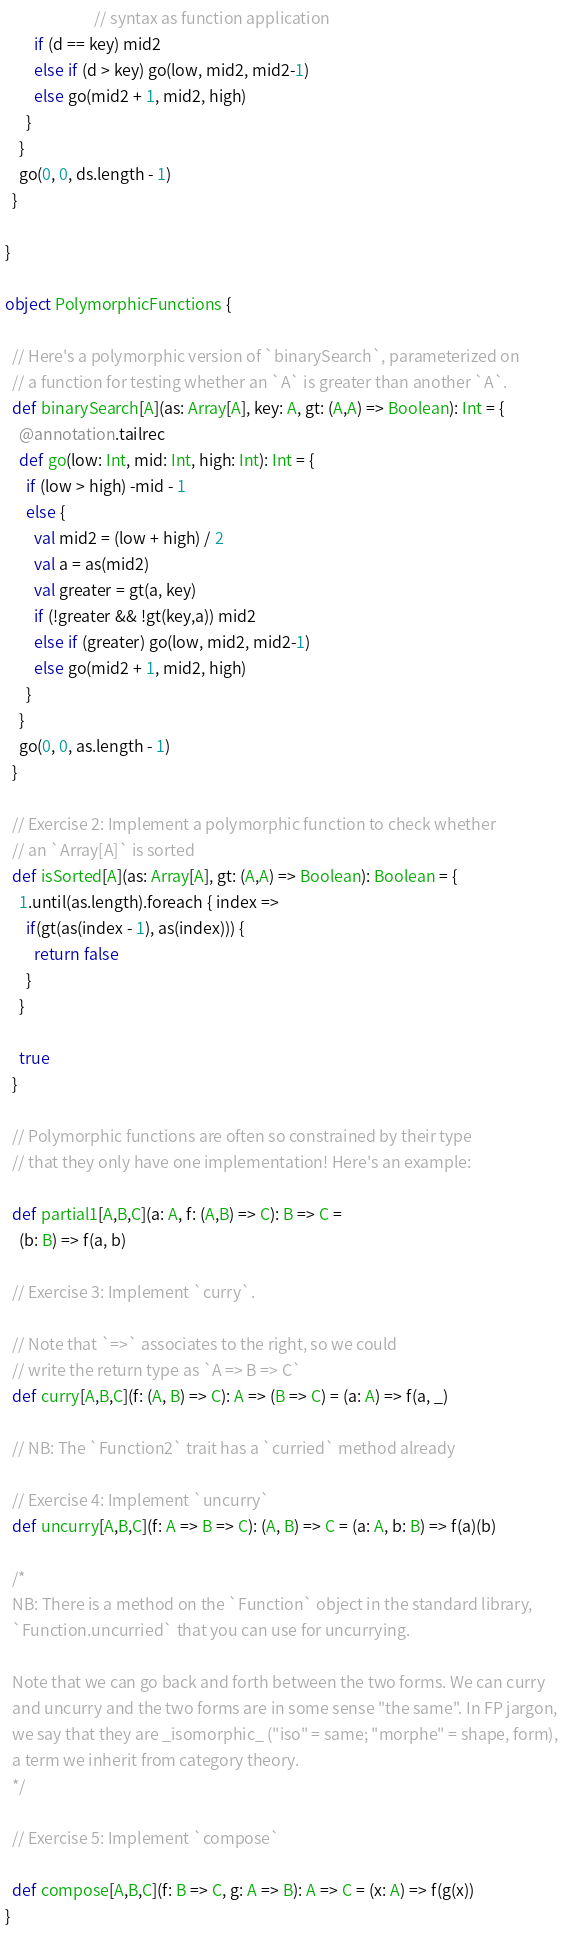Convert code to text. <code><loc_0><loc_0><loc_500><loc_500><_Scala_>                         // syntax as function application
        if (d == key) mid2
        else if (d > key) go(low, mid2, mid2-1)
        else go(mid2 + 1, mid2, high)
      }
    }
    go(0, 0, ds.length - 1)
  }

}

object PolymorphicFunctions {

  // Here's a polymorphic version of `binarySearch`, parameterized on
  // a function for testing whether an `A` is greater than another `A`.
  def binarySearch[A](as: Array[A], key: A, gt: (A,A) => Boolean): Int = {
    @annotation.tailrec
    def go(low: Int, mid: Int, high: Int): Int = {
      if (low > high) -mid - 1
      else {
        val mid2 = (low + high) / 2
        val a = as(mid2)
        val greater = gt(a, key)
        if (!greater && !gt(key,a)) mid2
        else if (greater) go(low, mid2, mid2-1)
        else go(mid2 + 1, mid2, high)
      }
    }
    go(0, 0, as.length - 1)
  }

  // Exercise 2: Implement a polymorphic function to check whether
  // an `Array[A]` is sorted
  def isSorted[A](as: Array[A], gt: (A,A) => Boolean): Boolean = {
    1.until(as.length).foreach { index =>
      if(gt(as(index - 1), as(index))) {
        return false
      }
    }

    true
  }

  // Polymorphic functions are often so constrained by their type
  // that they only have one implementation! Here's an example:

  def partial1[A,B,C](a: A, f: (A,B) => C): B => C =
    (b: B) => f(a, b)

  // Exercise 3: Implement `curry`.

  // Note that `=>` associates to the right, so we could
  // write the return type as `A => B => C`
  def curry[A,B,C](f: (A, B) => C): A => (B => C) = (a: A) => f(a, _)

  // NB: The `Function2` trait has a `curried` method already

  // Exercise 4: Implement `uncurry`
  def uncurry[A,B,C](f: A => B => C): (A, B) => C = (a: A, b: B) => f(a)(b)

  /*
  NB: There is a method on the `Function` object in the standard library,
  `Function.uncurried` that you can use for uncurrying.

  Note that we can go back and forth between the two forms. We can curry
  and uncurry and the two forms are in some sense "the same". In FP jargon,
  we say that they are _isomorphic_ ("iso" = same; "morphe" = shape, form),
  a term we inherit from category theory.
  */

  // Exercise 5: Implement `compose`

  def compose[A,B,C](f: B => C, g: A => B): A => C = (x: A) => f(g(x))
}
</code> 